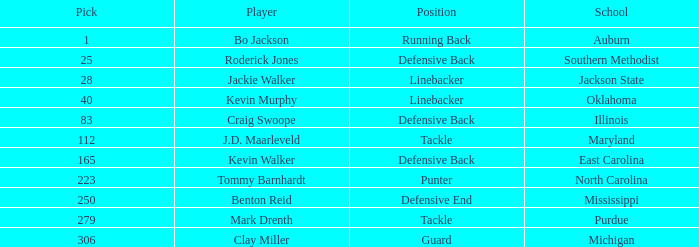What was the highest guard picked? 306.0. 